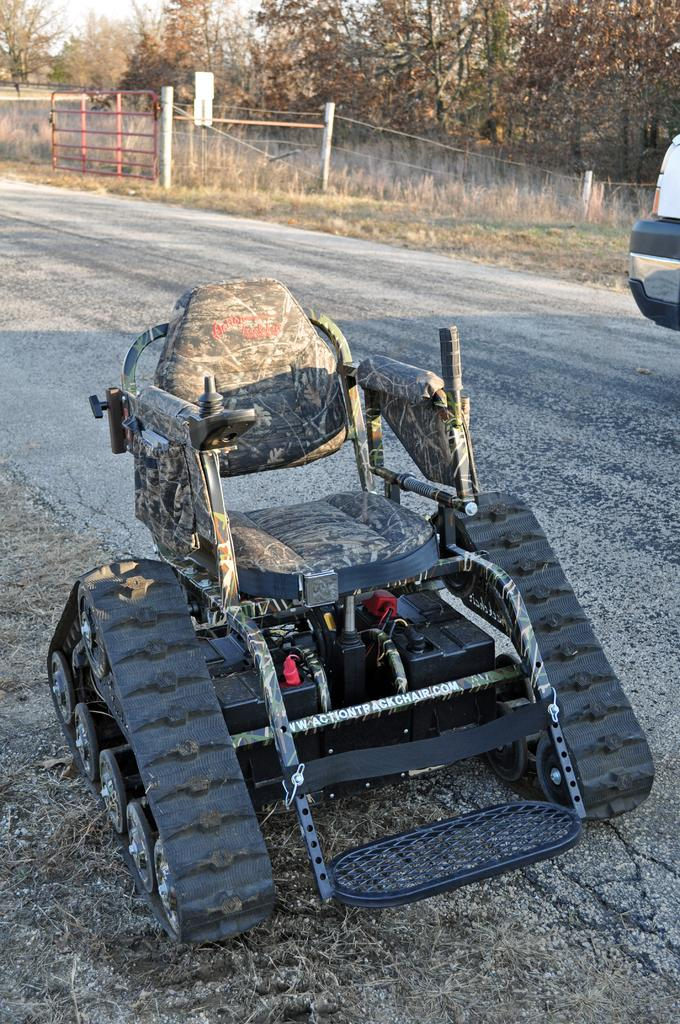What can be seen on the road in the image? There are vehicles on the road in the image. What type of vegetation is present in the image? There are trees in the image. What type of drink is being prepared in the oven in the image? There is no oven or drink preparation present in the image. What type of cable can be seen connecting the trees in the image? There are no cables connecting the trees in the image. 